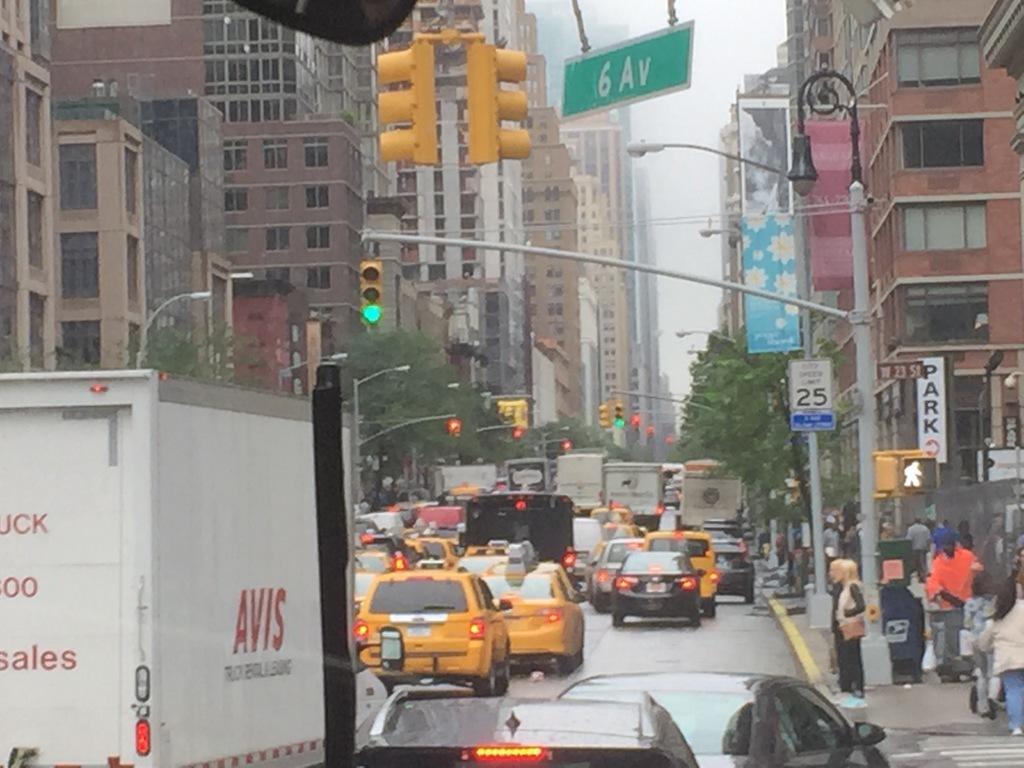What does the back of the truck say?
Your answer should be very brief. Avis. What is on the side of the truck?
Give a very brief answer. Avis. 